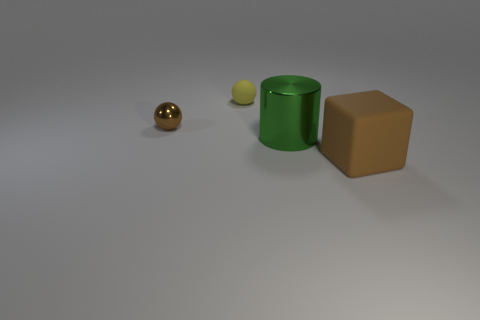Are there any patterns or text on the objects? No, all the objects in the image are devoid of any distinguishable patterns or text, showcasing smooth and uniform surfaces. How does the lighting in the image affect the mood or appearance? The image is lit in a subtle manner, casting soft shadows on the ground and accentuating the objects’ shapes and material properties, creating a calm and minimalist aesthetic. 